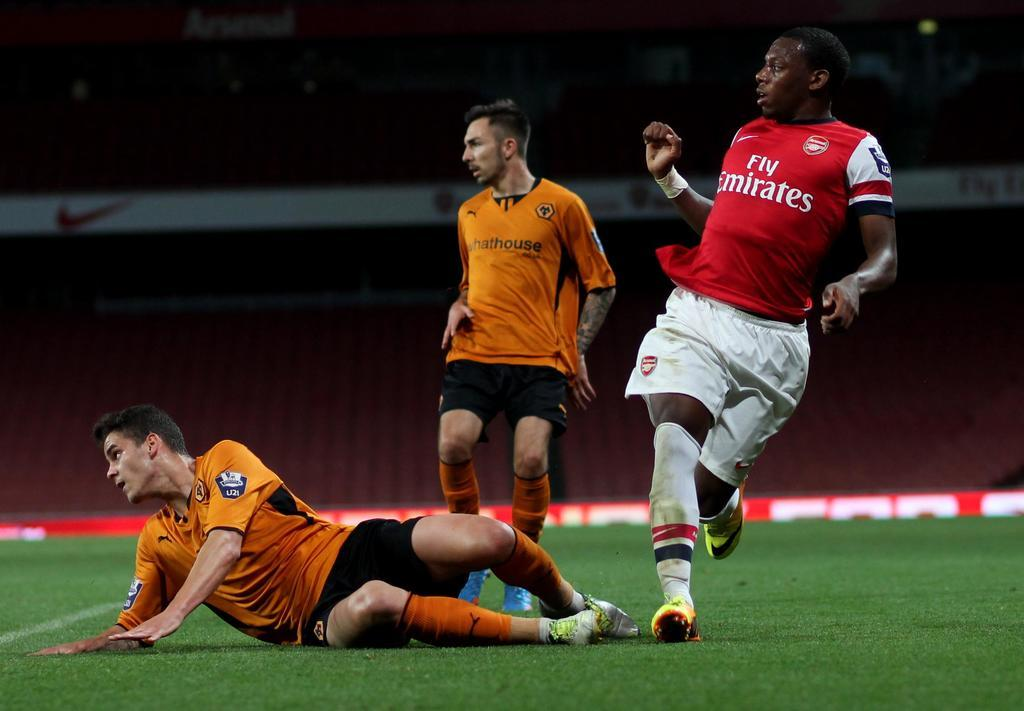<image>
Create a compact narrative representing the image presented. A soccer player wearing a Fly Emirates jersey is on the field next to two players in orange jerseys. 